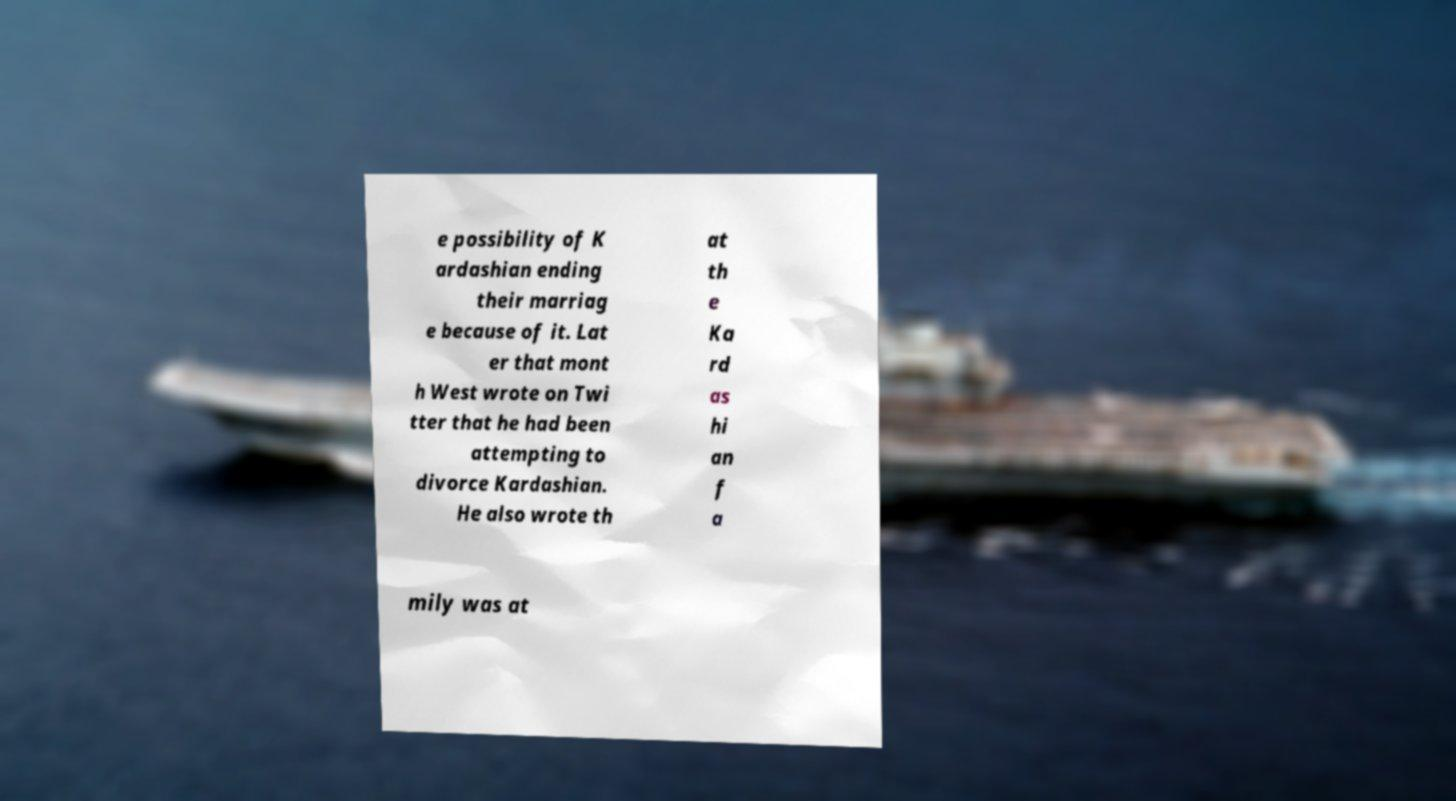Could you extract and type out the text from this image? e possibility of K ardashian ending their marriag e because of it. Lat er that mont h West wrote on Twi tter that he had been attempting to divorce Kardashian. He also wrote th at th e Ka rd as hi an f a mily was at 